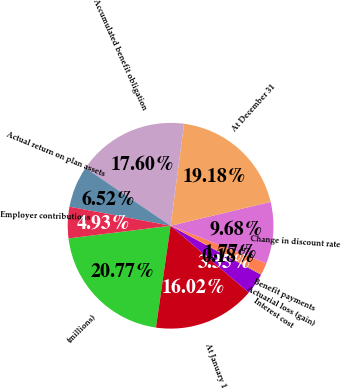<chart> <loc_0><loc_0><loc_500><loc_500><pie_chart><fcel>(millions)<fcel>At January 1<fcel>Interest cost<fcel>Actuarial loss (gain)<fcel>Benefit payments<fcel>Change in discount rate<fcel>At December 31<fcel>Accumulated benefit obligation<fcel>Actual return on plan assets<fcel>Employer contributions<nl><fcel>20.77%<fcel>16.02%<fcel>3.35%<fcel>0.18%<fcel>1.77%<fcel>9.68%<fcel>19.18%<fcel>17.6%<fcel>6.52%<fcel>4.93%<nl></chart> 